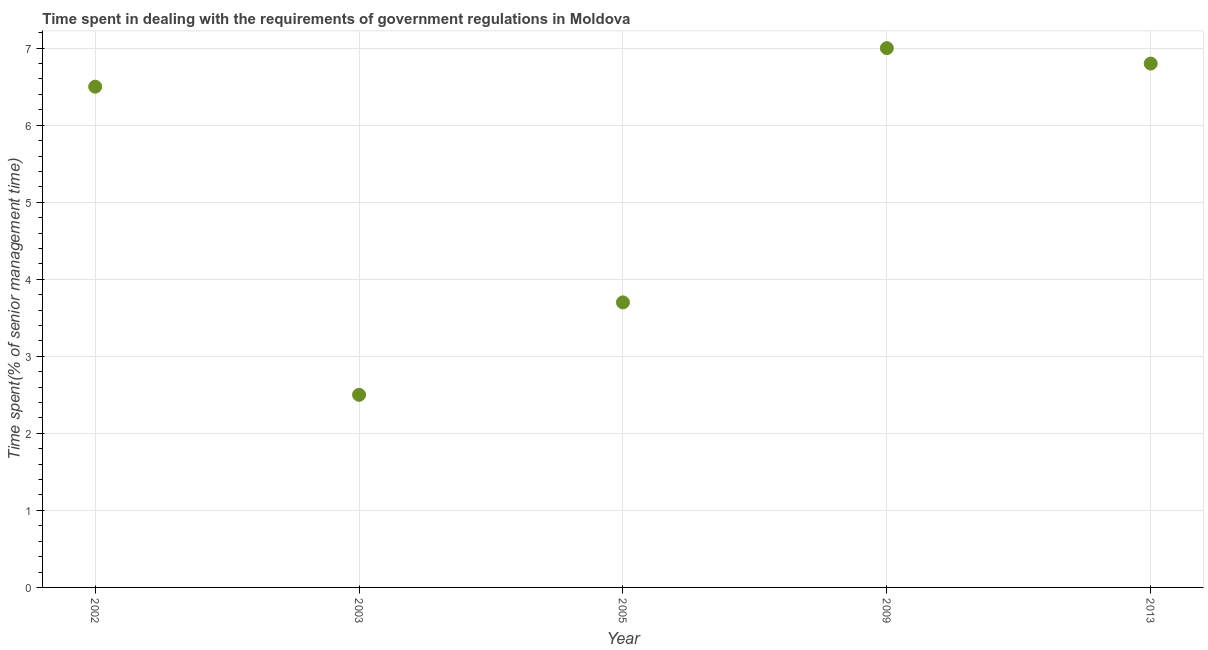Across all years, what is the maximum time spent in dealing with government regulations?
Keep it short and to the point. 7. What is the difference between the time spent in dealing with government regulations in 2002 and 2003?
Your response must be concise. 4. What is the median time spent in dealing with government regulations?
Offer a terse response. 6.5. What is the ratio of the time spent in dealing with government regulations in 2005 to that in 2009?
Ensure brevity in your answer.  0.53. Is the time spent in dealing with government regulations in 2003 less than that in 2009?
Offer a very short reply. Yes. Is the difference between the time spent in dealing with government regulations in 2002 and 2013 greater than the difference between any two years?
Make the answer very short. No. What is the difference between the highest and the second highest time spent in dealing with government regulations?
Your answer should be compact. 0.2. In how many years, is the time spent in dealing with government regulations greater than the average time spent in dealing with government regulations taken over all years?
Your response must be concise. 3. How many dotlines are there?
Provide a short and direct response. 1. How many years are there in the graph?
Give a very brief answer. 5. Are the values on the major ticks of Y-axis written in scientific E-notation?
Offer a terse response. No. What is the title of the graph?
Provide a succinct answer. Time spent in dealing with the requirements of government regulations in Moldova. What is the label or title of the Y-axis?
Give a very brief answer. Time spent(% of senior management time). What is the Time spent(% of senior management time) in 2002?
Ensure brevity in your answer.  6.5. What is the Time spent(% of senior management time) in 2009?
Your answer should be very brief. 7. What is the difference between the Time spent(% of senior management time) in 2002 and 2003?
Your response must be concise. 4. What is the difference between the Time spent(% of senior management time) in 2002 and 2009?
Make the answer very short. -0.5. What is the difference between the Time spent(% of senior management time) in 2003 and 2009?
Provide a short and direct response. -4.5. What is the difference between the Time spent(% of senior management time) in 2003 and 2013?
Give a very brief answer. -4.3. What is the difference between the Time spent(% of senior management time) in 2005 and 2009?
Keep it short and to the point. -3.3. What is the ratio of the Time spent(% of senior management time) in 2002 to that in 2005?
Your response must be concise. 1.76. What is the ratio of the Time spent(% of senior management time) in 2002 to that in 2009?
Give a very brief answer. 0.93. What is the ratio of the Time spent(% of senior management time) in 2002 to that in 2013?
Offer a terse response. 0.96. What is the ratio of the Time spent(% of senior management time) in 2003 to that in 2005?
Provide a short and direct response. 0.68. What is the ratio of the Time spent(% of senior management time) in 2003 to that in 2009?
Provide a succinct answer. 0.36. What is the ratio of the Time spent(% of senior management time) in 2003 to that in 2013?
Provide a short and direct response. 0.37. What is the ratio of the Time spent(% of senior management time) in 2005 to that in 2009?
Your response must be concise. 0.53. What is the ratio of the Time spent(% of senior management time) in 2005 to that in 2013?
Your answer should be very brief. 0.54. 